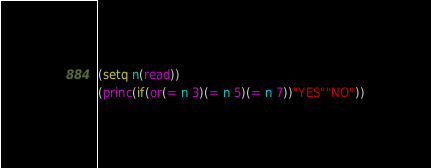Convert code to text. <code><loc_0><loc_0><loc_500><loc_500><_Lisp_>(setq n(read))
(princ(if(or(= n 3)(= n 5)(= n 7))"YES""NO"))</code> 